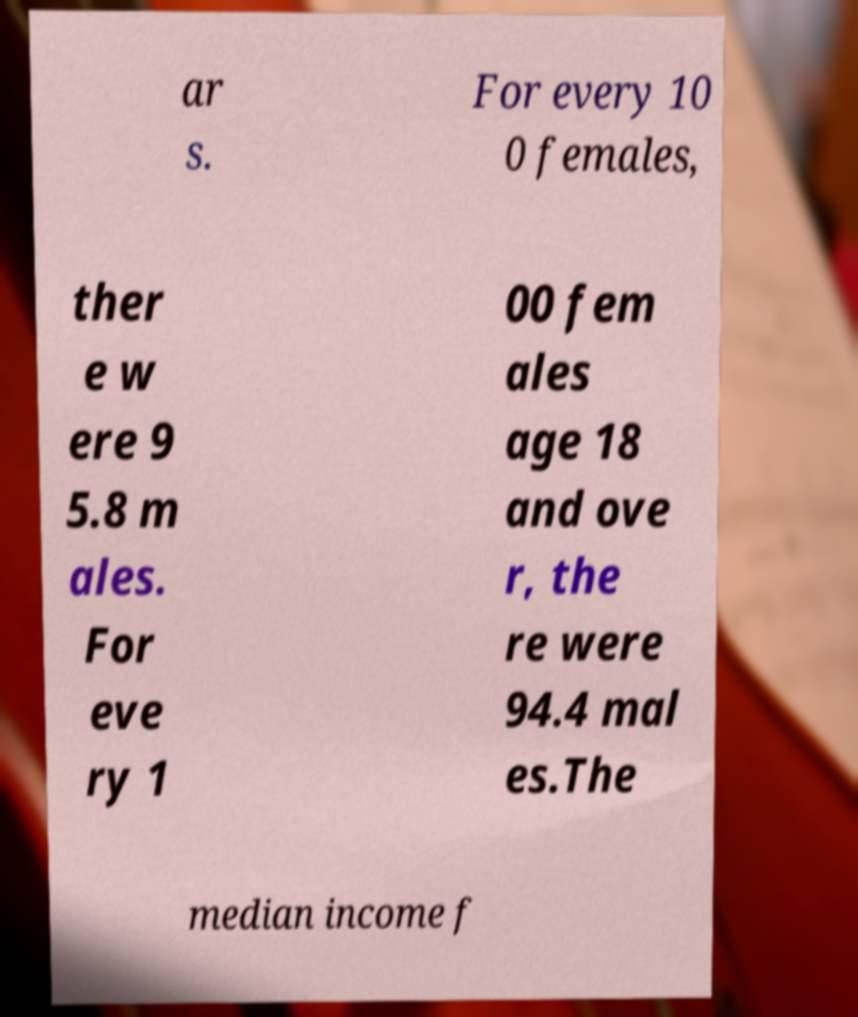Please identify and transcribe the text found in this image. ar s. For every 10 0 females, ther e w ere 9 5.8 m ales. For eve ry 1 00 fem ales age 18 and ove r, the re were 94.4 mal es.The median income f 